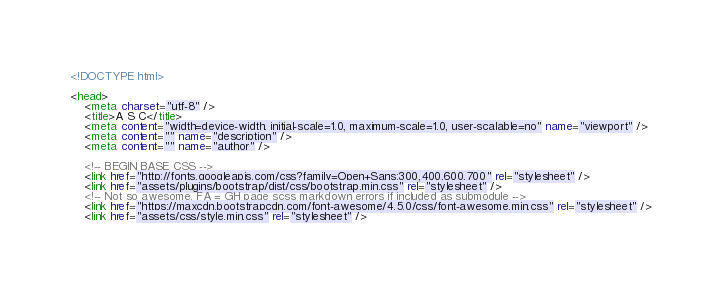<code> <loc_0><loc_0><loc_500><loc_500><_HTML_><!DOCTYPE html>

<head>
    <meta charset="utf-8" />
    <title>A S C</title>
    <meta content="width=device-width, initial-scale=1.0, maximum-scale=1.0, user-scalable=no" name="viewport" />
    <meta content="" name="description" />
    <meta content="" name="author" />

    <!-- BEGIN BASE CSS -->
    <link href="http://fonts.googleapis.com/css?family=Open+Sans:300,400,600,700" rel="stylesheet" />
    <link href="assets/plugins/bootstrap/dist/css/bootstrap.min.css" rel="stylesheet" />
    <!-- Not so awesome. FA = GH page scss markdown errors if included as submodule -->
    <link href="https://maxcdn.bootstrapcdn.com/font-awesome/4.5.0/css/font-awesome.min.css" rel="stylesheet" />
    <link href="assets/css/style.min.css" rel="stylesheet" /></code> 